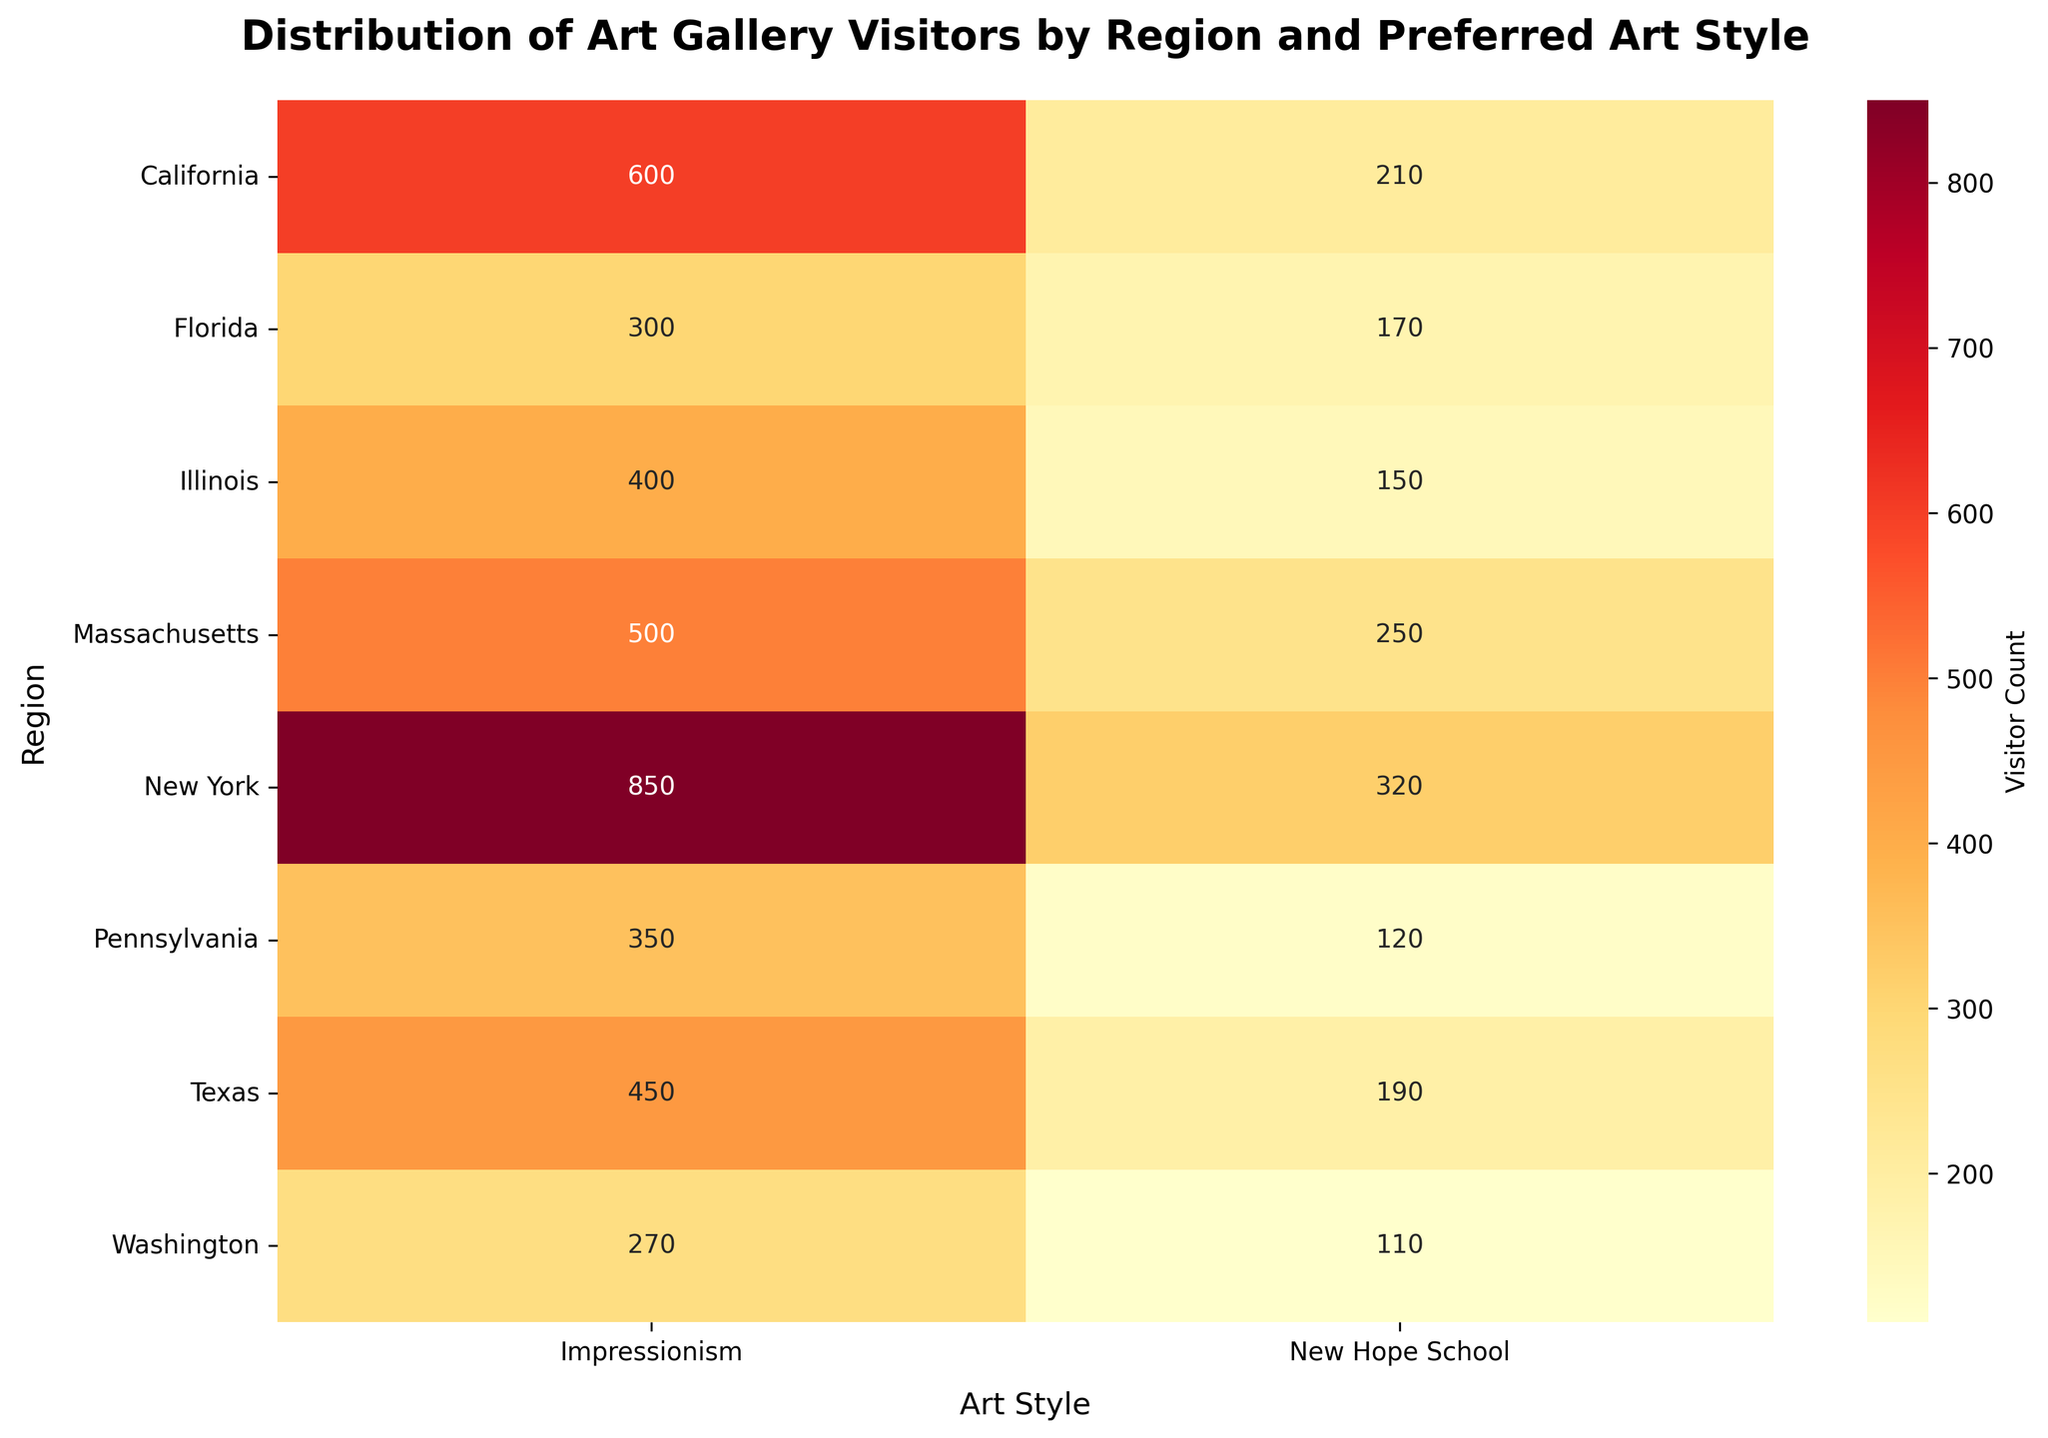what is the title of the heatmap? The title can be found at the top of the heatmap. It provides an overview of what the data represents.
Answer: Distribution of Art Gallery Visitors by Region and Preferred Art Style Which region has the highest number of visitors preferring Impressionism? Look at the values in the Impressionism column and identify the highest number.
Answer: New York How many visitors prefer the New Hope School style in California? Refer to the cell where the Art Style is New Hope School and the Region is California.
Answer: 210 What is the total number of visitors who prefer the Impressionism style across all regions? Sum all the values in the Impressionism column.
Answer: 3720 Which region has the fewest visitors for the New Hope School style? Identify the smallest number in the New Hope School column.
Answer: Washington What is the difference in visitor count between Impressionism and New Hope School styles in Texas? Subtract the number of New Hope School visitors from the number of Impressionism visitors in Texas.
Answer: 260 How many regions have more than 500 visitors preferring Impressionism? Count the regions where the Impressionism value is greater than 500.
Answer: 1 What is the average number of visitors for the New Hope School style across all regions? Sum all the New Hope School values and divide by the number of regions (8).
Answer: 190 In which region is the difference between visitors preferring Impressionism and New Hope School the smallest? Calculate the difference for each region and identify the smallest one.
Answer: Washington 